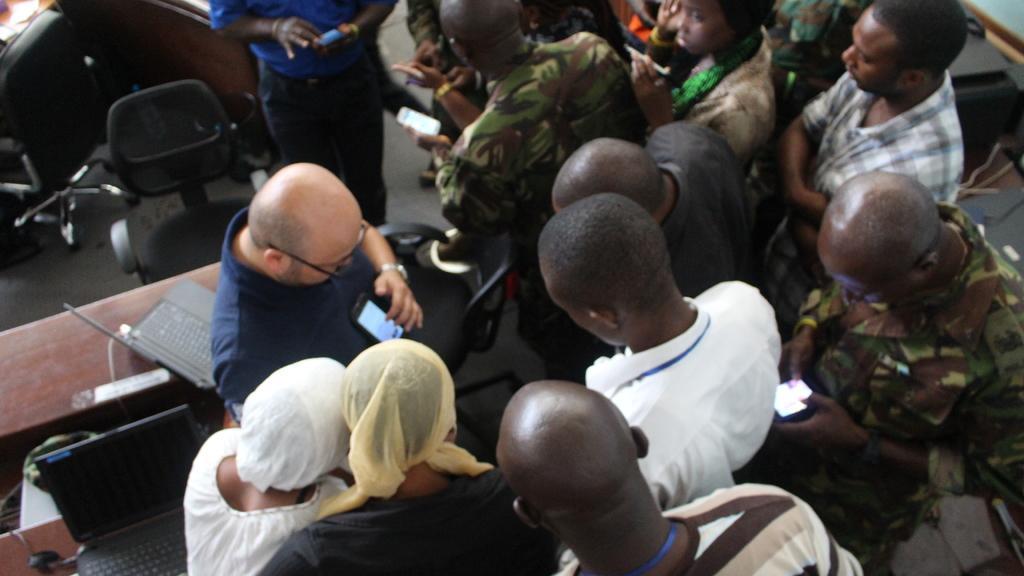In one or two sentences, can you explain what this image depicts? There are persons in different color dresses on a floor. On the left side, there are laptops on the tables. In the background, there are chairs on the floor. 